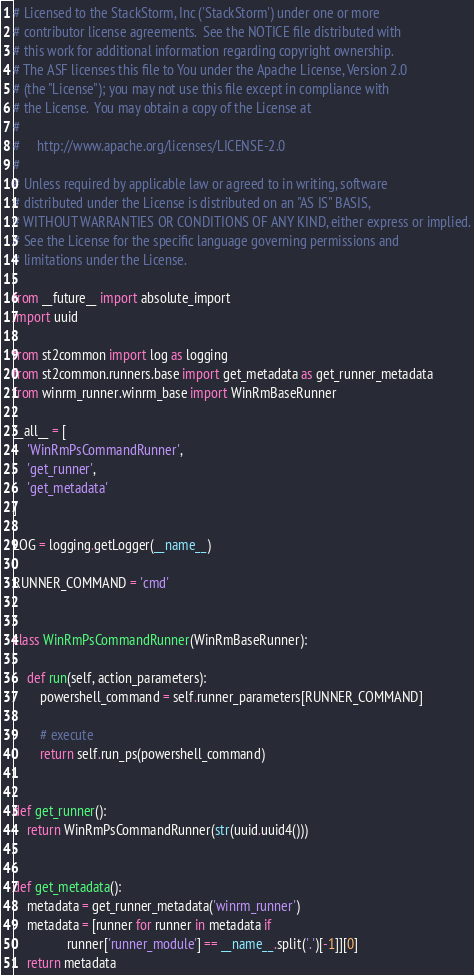Convert code to text. <code><loc_0><loc_0><loc_500><loc_500><_Python_># Licensed to the StackStorm, Inc ('StackStorm') under one or more
# contributor license agreements.  See the NOTICE file distributed with
# this work for additional information regarding copyright ownership.
# The ASF licenses this file to You under the Apache License, Version 2.0
# (the "License"); you may not use this file except in compliance with
# the License.  You may obtain a copy of the License at
#
#     http://www.apache.org/licenses/LICENSE-2.0
#
# Unless required by applicable law or agreed to in writing, software
# distributed under the License is distributed on an "AS IS" BASIS,
# WITHOUT WARRANTIES OR CONDITIONS OF ANY KIND, either express or implied.
# See the License for the specific language governing permissions and
# limitations under the License.

from __future__ import absolute_import
import uuid

from st2common import log as logging
from st2common.runners.base import get_metadata as get_runner_metadata
from winrm_runner.winrm_base import WinRmBaseRunner

__all__ = [
    'WinRmPsCommandRunner',
    'get_runner',
    'get_metadata'
]

LOG = logging.getLogger(__name__)

RUNNER_COMMAND = 'cmd'


class WinRmPsCommandRunner(WinRmBaseRunner):

    def run(self, action_parameters):
        powershell_command = self.runner_parameters[RUNNER_COMMAND]

        # execute
        return self.run_ps(powershell_command)


def get_runner():
    return WinRmPsCommandRunner(str(uuid.uuid4()))


def get_metadata():
    metadata = get_runner_metadata('winrm_runner')
    metadata = [runner for runner in metadata if
                runner['runner_module'] == __name__.split('.')[-1]][0]
    return metadata
</code> 